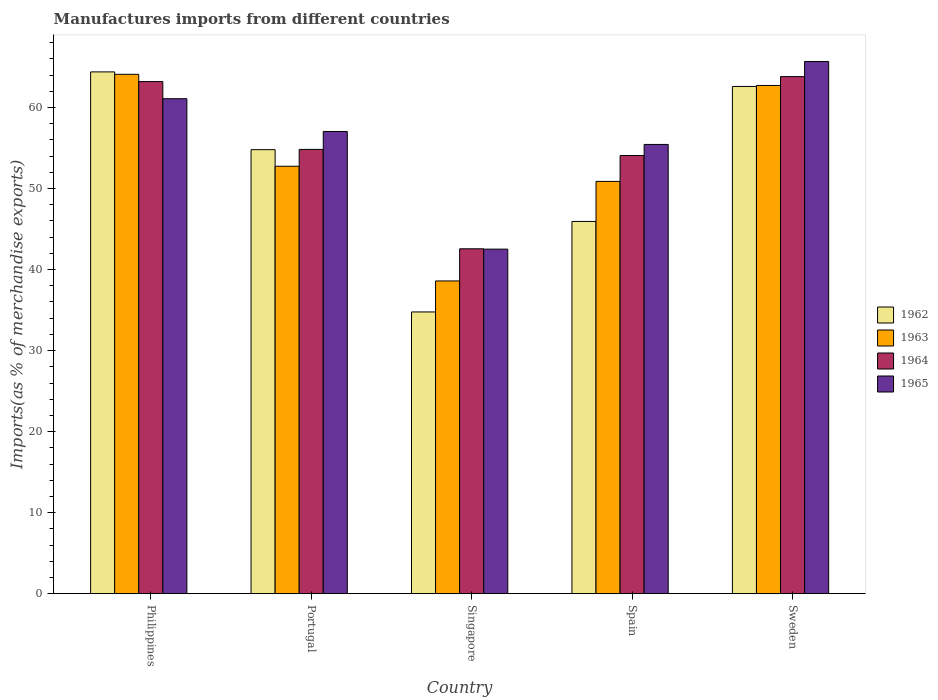Are the number of bars per tick equal to the number of legend labels?
Offer a very short reply. Yes. Are the number of bars on each tick of the X-axis equal?
Your response must be concise. Yes. How many bars are there on the 3rd tick from the left?
Ensure brevity in your answer.  4. How many bars are there on the 5th tick from the right?
Your response must be concise. 4. What is the label of the 3rd group of bars from the left?
Your answer should be compact. Singapore. In how many cases, is the number of bars for a given country not equal to the number of legend labels?
Make the answer very short. 0. What is the percentage of imports to different countries in 1964 in Singapore?
Your response must be concise. 42.56. Across all countries, what is the maximum percentage of imports to different countries in 1963?
Your answer should be very brief. 64.1. Across all countries, what is the minimum percentage of imports to different countries in 1964?
Make the answer very short. 42.56. In which country was the percentage of imports to different countries in 1965 maximum?
Ensure brevity in your answer.  Sweden. In which country was the percentage of imports to different countries in 1964 minimum?
Your answer should be compact. Singapore. What is the total percentage of imports to different countries in 1962 in the graph?
Provide a short and direct response. 262.5. What is the difference between the percentage of imports to different countries in 1962 in Portugal and that in Sweden?
Your answer should be very brief. -7.8. What is the difference between the percentage of imports to different countries in 1965 in Philippines and the percentage of imports to different countries in 1963 in Sweden?
Make the answer very short. -1.64. What is the average percentage of imports to different countries in 1963 per country?
Make the answer very short. 53.81. What is the difference between the percentage of imports to different countries of/in 1964 and percentage of imports to different countries of/in 1963 in Singapore?
Your answer should be compact. 3.97. What is the ratio of the percentage of imports to different countries in 1963 in Portugal to that in Spain?
Ensure brevity in your answer.  1.04. Is the percentage of imports to different countries in 1962 in Philippines less than that in Sweden?
Your response must be concise. No. Is the difference between the percentage of imports to different countries in 1964 in Portugal and Spain greater than the difference between the percentage of imports to different countries in 1963 in Portugal and Spain?
Give a very brief answer. No. What is the difference between the highest and the second highest percentage of imports to different countries in 1963?
Provide a succinct answer. 11.35. What is the difference between the highest and the lowest percentage of imports to different countries in 1964?
Offer a very short reply. 21.25. In how many countries, is the percentage of imports to different countries in 1962 greater than the average percentage of imports to different countries in 1962 taken over all countries?
Ensure brevity in your answer.  3. What does the 1st bar from the right in Philippines represents?
Your answer should be compact. 1965. Is it the case that in every country, the sum of the percentage of imports to different countries in 1964 and percentage of imports to different countries in 1962 is greater than the percentage of imports to different countries in 1965?
Ensure brevity in your answer.  Yes. How many countries are there in the graph?
Your answer should be compact. 5. What is the difference between two consecutive major ticks on the Y-axis?
Ensure brevity in your answer.  10. Are the values on the major ticks of Y-axis written in scientific E-notation?
Give a very brief answer. No. Where does the legend appear in the graph?
Your answer should be very brief. Center right. How many legend labels are there?
Offer a very short reply. 4. How are the legend labels stacked?
Your response must be concise. Vertical. What is the title of the graph?
Offer a terse response. Manufactures imports from different countries. What is the label or title of the Y-axis?
Your answer should be very brief. Imports(as % of merchandise exports). What is the Imports(as % of merchandise exports) in 1962 in Philippines?
Make the answer very short. 64.4. What is the Imports(as % of merchandise exports) in 1963 in Philippines?
Keep it short and to the point. 64.1. What is the Imports(as % of merchandise exports) in 1964 in Philippines?
Offer a very short reply. 63.2. What is the Imports(as % of merchandise exports) of 1965 in Philippines?
Offer a terse response. 61.09. What is the Imports(as % of merchandise exports) in 1962 in Portugal?
Make the answer very short. 54.8. What is the Imports(as % of merchandise exports) in 1963 in Portugal?
Keep it short and to the point. 52.75. What is the Imports(as % of merchandise exports) in 1964 in Portugal?
Ensure brevity in your answer.  54.83. What is the Imports(as % of merchandise exports) of 1965 in Portugal?
Offer a very short reply. 57.04. What is the Imports(as % of merchandise exports) in 1962 in Singapore?
Your answer should be compact. 34.77. What is the Imports(as % of merchandise exports) in 1963 in Singapore?
Your answer should be compact. 38.6. What is the Imports(as % of merchandise exports) in 1964 in Singapore?
Ensure brevity in your answer.  42.56. What is the Imports(as % of merchandise exports) of 1965 in Singapore?
Provide a short and direct response. 42.52. What is the Imports(as % of merchandise exports) of 1962 in Spain?
Give a very brief answer. 45.94. What is the Imports(as % of merchandise exports) in 1963 in Spain?
Your response must be concise. 50.88. What is the Imports(as % of merchandise exports) in 1964 in Spain?
Make the answer very short. 54.08. What is the Imports(as % of merchandise exports) in 1965 in Spain?
Ensure brevity in your answer.  55.44. What is the Imports(as % of merchandise exports) in 1962 in Sweden?
Your answer should be compact. 62.6. What is the Imports(as % of merchandise exports) of 1963 in Sweden?
Ensure brevity in your answer.  62.72. What is the Imports(as % of merchandise exports) of 1964 in Sweden?
Provide a short and direct response. 63.82. What is the Imports(as % of merchandise exports) in 1965 in Sweden?
Make the answer very short. 65.68. Across all countries, what is the maximum Imports(as % of merchandise exports) in 1962?
Provide a succinct answer. 64.4. Across all countries, what is the maximum Imports(as % of merchandise exports) of 1963?
Your response must be concise. 64.1. Across all countries, what is the maximum Imports(as % of merchandise exports) in 1964?
Provide a succinct answer. 63.82. Across all countries, what is the maximum Imports(as % of merchandise exports) of 1965?
Your answer should be very brief. 65.68. Across all countries, what is the minimum Imports(as % of merchandise exports) in 1962?
Ensure brevity in your answer.  34.77. Across all countries, what is the minimum Imports(as % of merchandise exports) of 1963?
Offer a very short reply. 38.6. Across all countries, what is the minimum Imports(as % of merchandise exports) of 1964?
Make the answer very short. 42.56. Across all countries, what is the minimum Imports(as % of merchandise exports) of 1965?
Your answer should be compact. 42.52. What is the total Imports(as % of merchandise exports) of 1962 in the graph?
Your answer should be compact. 262.5. What is the total Imports(as % of merchandise exports) of 1963 in the graph?
Provide a succinct answer. 269.05. What is the total Imports(as % of merchandise exports) in 1964 in the graph?
Keep it short and to the point. 278.49. What is the total Imports(as % of merchandise exports) of 1965 in the graph?
Provide a short and direct response. 281.78. What is the difference between the Imports(as % of merchandise exports) in 1962 in Philippines and that in Portugal?
Keep it short and to the point. 9.6. What is the difference between the Imports(as % of merchandise exports) in 1963 in Philippines and that in Portugal?
Provide a succinct answer. 11.35. What is the difference between the Imports(as % of merchandise exports) of 1964 in Philippines and that in Portugal?
Your answer should be very brief. 8.37. What is the difference between the Imports(as % of merchandise exports) in 1965 in Philippines and that in Portugal?
Provide a succinct answer. 4.04. What is the difference between the Imports(as % of merchandise exports) of 1962 in Philippines and that in Singapore?
Make the answer very short. 29.63. What is the difference between the Imports(as % of merchandise exports) of 1963 in Philippines and that in Singapore?
Provide a short and direct response. 25.5. What is the difference between the Imports(as % of merchandise exports) of 1964 in Philippines and that in Singapore?
Offer a very short reply. 20.64. What is the difference between the Imports(as % of merchandise exports) of 1965 in Philippines and that in Singapore?
Offer a terse response. 18.57. What is the difference between the Imports(as % of merchandise exports) of 1962 in Philippines and that in Spain?
Your answer should be very brief. 18.46. What is the difference between the Imports(as % of merchandise exports) of 1963 in Philippines and that in Spain?
Your answer should be very brief. 13.22. What is the difference between the Imports(as % of merchandise exports) in 1964 in Philippines and that in Spain?
Give a very brief answer. 9.12. What is the difference between the Imports(as % of merchandise exports) in 1965 in Philippines and that in Spain?
Offer a terse response. 5.64. What is the difference between the Imports(as % of merchandise exports) of 1962 in Philippines and that in Sweden?
Your answer should be compact. 1.8. What is the difference between the Imports(as % of merchandise exports) in 1963 in Philippines and that in Sweden?
Provide a short and direct response. 1.37. What is the difference between the Imports(as % of merchandise exports) of 1964 in Philippines and that in Sweden?
Ensure brevity in your answer.  -0.61. What is the difference between the Imports(as % of merchandise exports) in 1965 in Philippines and that in Sweden?
Offer a terse response. -4.6. What is the difference between the Imports(as % of merchandise exports) of 1962 in Portugal and that in Singapore?
Your response must be concise. 20.03. What is the difference between the Imports(as % of merchandise exports) of 1963 in Portugal and that in Singapore?
Keep it short and to the point. 14.16. What is the difference between the Imports(as % of merchandise exports) of 1964 in Portugal and that in Singapore?
Provide a short and direct response. 12.27. What is the difference between the Imports(as % of merchandise exports) of 1965 in Portugal and that in Singapore?
Offer a very short reply. 14.52. What is the difference between the Imports(as % of merchandise exports) of 1962 in Portugal and that in Spain?
Your response must be concise. 8.86. What is the difference between the Imports(as % of merchandise exports) in 1963 in Portugal and that in Spain?
Make the answer very short. 1.87. What is the difference between the Imports(as % of merchandise exports) in 1964 in Portugal and that in Spain?
Give a very brief answer. 0.75. What is the difference between the Imports(as % of merchandise exports) of 1965 in Portugal and that in Spain?
Give a very brief answer. 1.6. What is the difference between the Imports(as % of merchandise exports) of 1962 in Portugal and that in Sweden?
Provide a short and direct response. -7.8. What is the difference between the Imports(as % of merchandise exports) in 1963 in Portugal and that in Sweden?
Your answer should be compact. -9.97. What is the difference between the Imports(as % of merchandise exports) in 1964 in Portugal and that in Sweden?
Your answer should be compact. -8.99. What is the difference between the Imports(as % of merchandise exports) in 1965 in Portugal and that in Sweden?
Your response must be concise. -8.64. What is the difference between the Imports(as % of merchandise exports) of 1962 in Singapore and that in Spain?
Provide a succinct answer. -11.17. What is the difference between the Imports(as % of merchandise exports) in 1963 in Singapore and that in Spain?
Your response must be concise. -12.29. What is the difference between the Imports(as % of merchandise exports) of 1964 in Singapore and that in Spain?
Your answer should be very brief. -11.51. What is the difference between the Imports(as % of merchandise exports) of 1965 in Singapore and that in Spain?
Your answer should be very brief. -12.92. What is the difference between the Imports(as % of merchandise exports) of 1962 in Singapore and that in Sweden?
Provide a succinct answer. -27.83. What is the difference between the Imports(as % of merchandise exports) of 1963 in Singapore and that in Sweden?
Provide a short and direct response. -24.13. What is the difference between the Imports(as % of merchandise exports) in 1964 in Singapore and that in Sweden?
Make the answer very short. -21.25. What is the difference between the Imports(as % of merchandise exports) of 1965 in Singapore and that in Sweden?
Make the answer very short. -23.16. What is the difference between the Imports(as % of merchandise exports) of 1962 in Spain and that in Sweden?
Offer a terse response. -16.66. What is the difference between the Imports(as % of merchandise exports) in 1963 in Spain and that in Sweden?
Provide a short and direct response. -11.84. What is the difference between the Imports(as % of merchandise exports) in 1964 in Spain and that in Sweden?
Offer a very short reply. -9.74. What is the difference between the Imports(as % of merchandise exports) of 1965 in Spain and that in Sweden?
Your answer should be compact. -10.24. What is the difference between the Imports(as % of merchandise exports) in 1962 in Philippines and the Imports(as % of merchandise exports) in 1963 in Portugal?
Offer a terse response. 11.65. What is the difference between the Imports(as % of merchandise exports) in 1962 in Philippines and the Imports(as % of merchandise exports) in 1964 in Portugal?
Provide a short and direct response. 9.57. What is the difference between the Imports(as % of merchandise exports) of 1962 in Philippines and the Imports(as % of merchandise exports) of 1965 in Portugal?
Provide a short and direct response. 7.35. What is the difference between the Imports(as % of merchandise exports) in 1963 in Philippines and the Imports(as % of merchandise exports) in 1964 in Portugal?
Your answer should be compact. 9.27. What is the difference between the Imports(as % of merchandise exports) in 1963 in Philippines and the Imports(as % of merchandise exports) in 1965 in Portugal?
Ensure brevity in your answer.  7.05. What is the difference between the Imports(as % of merchandise exports) in 1964 in Philippines and the Imports(as % of merchandise exports) in 1965 in Portugal?
Ensure brevity in your answer.  6.16. What is the difference between the Imports(as % of merchandise exports) of 1962 in Philippines and the Imports(as % of merchandise exports) of 1963 in Singapore?
Your answer should be compact. 25.8. What is the difference between the Imports(as % of merchandise exports) of 1962 in Philippines and the Imports(as % of merchandise exports) of 1964 in Singapore?
Your answer should be compact. 21.83. What is the difference between the Imports(as % of merchandise exports) in 1962 in Philippines and the Imports(as % of merchandise exports) in 1965 in Singapore?
Your answer should be very brief. 21.87. What is the difference between the Imports(as % of merchandise exports) of 1963 in Philippines and the Imports(as % of merchandise exports) of 1964 in Singapore?
Make the answer very short. 21.53. What is the difference between the Imports(as % of merchandise exports) of 1963 in Philippines and the Imports(as % of merchandise exports) of 1965 in Singapore?
Your answer should be compact. 21.58. What is the difference between the Imports(as % of merchandise exports) of 1964 in Philippines and the Imports(as % of merchandise exports) of 1965 in Singapore?
Provide a short and direct response. 20.68. What is the difference between the Imports(as % of merchandise exports) in 1962 in Philippines and the Imports(as % of merchandise exports) in 1963 in Spain?
Your answer should be compact. 13.51. What is the difference between the Imports(as % of merchandise exports) of 1962 in Philippines and the Imports(as % of merchandise exports) of 1964 in Spain?
Your answer should be compact. 10.32. What is the difference between the Imports(as % of merchandise exports) in 1962 in Philippines and the Imports(as % of merchandise exports) in 1965 in Spain?
Provide a succinct answer. 8.95. What is the difference between the Imports(as % of merchandise exports) of 1963 in Philippines and the Imports(as % of merchandise exports) of 1964 in Spain?
Your answer should be very brief. 10.02. What is the difference between the Imports(as % of merchandise exports) of 1963 in Philippines and the Imports(as % of merchandise exports) of 1965 in Spain?
Your answer should be compact. 8.65. What is the difference between the Imports(as % of merchandise exports) in 1964 in Philippines and the Imports(as % of merchandise exports) in 1965 in Spain?
Your response must be concise. 7.76. What is the difference between the Imports(as % of merchandise exports) of 1962 in Philippines and the Imports(as % of merchandise exports) of 1963 in Sweden?
Offer a terse response. 1.67. What is the difference between the Imports(as % of merchandise exports) in 1962 in Philippines and the Imports(as % of merchandise exports) in 1964 in Sweden?
Offer a terse response. 0.58. What is the difference between the Imports(as % of merchandise exports) in 1962 in Philippines and the Imports(as % of merchandise exports) in 1965 in Sweden?
Offer a very short reply. -1.29. What is the difference between the Imports(as % of merchandise exports) of 1963 in Philippines and the Imports(as % of merchandise exports) of 1964 in Sweden?
Provide a short and direct response. 0.28. What is the difference between the Imports(as % of merchandise exports) of 1963 in Philippines and the Imports(as % of merchandise exports) of 1965 in Sweden?
Provide a succinct answer. -1.58. What is the difference between the Imports(as % of merchandise exports) in 1964 in Philippines and the Imports(as % of merchandise exports) in 1965 in Sweden?
Provide a short and direct response. -2.48. What is the difference between the Imports(as % of merchandise exports) of 1962 in Portugal and the Imports(as % of merchandise exports) of 1963 in Singapore?
Your answer should be compact. 16.2. What is the difference between the Imports(as % of merchandise exports) in 1962 in Portugal and the Imports(as % of merchandise exports) in 1964 in Singapore?
Make the answer very short. 12.23. What is the difference between the Imports(as % of merchandise exports) in 1962 in Portugal and the Imports(as % of merchandise exports) in 1965 in Singapore?
Ensure brevity in your answer.  12.28. What is the difference between the Imports(as % of merchandise exports) of 1963 in Portugal and the Imports(as % of merchandise exports) of 1964 in Singapore?
Keep it short and to the point. 10.19. What is the difference between the Imports(as % of merchandise exports) of 1963 in Portugal and the Imports(as % of merchandise exports) of 1965 in Singapore?
Offer a very short reply. 10.23. What is the difference between the Imports(as % of merchandise exports) in 1964 in Portugal and the Imports(as % of merchandise exports) in 1965 in Singapore?
Keep it short and to the point. 12.31. What is the difference between the Imports(as % of merchandise exports) in 1962 in Portugal and the Imports(as % of merchandise exports) in 1963 in Spain?
Your answer should be compact. 3.92. What is the difference between the Imports(as % of merchandise exports) of 1962 in Portugal and the Imports(as % of merchandise exports) of 1964 in Spain?
Keep it short and to the point. 0.72. What is the difference between the Imports(as % of merchandise exports) in 1962 in Portugal and the Imports(as % of merchandise exports) in 1965 in Spain?
Offer a very short reply. -0.65. What is the difference between the Imports(as % of merchandise exports) of 1963 in Portugal and the Imports(as % of merchandise exports) of 1964 in Spain?
Make the answer very short. -1.33. What is the difference between the Imports(as % of merchandise exports) in 1963 in Portugal and the Imports(as % of merchandise exports) in 1965 in Spain?
Provide a succinct answer. -2.69. What is the difference between the Imports(as % of merchandise exports) in 1964 in Portugal and the Imports(as % of merchandise exports) in 1965 in Spain?
Keep it short and to the point. -0.61. What is the difference between the Imports(as % of merchandise exports) in 1962 in Portugal and the Imports(as % of merchandise exports) in 1963 in Sweden?
Make the answer very short. -7.92. What is the difference between the Imports(as % of merchandise exports) in 1962 in Portugal and the Imports(as % of merchandise exports) in 1964 in Sweden?
Your response must be concise. -9.02. What is the difference between the Imports(as % of merchandise exports) in 1962 in Portugal and the Imports(as % of merchandise exports) in 1965 in Sweden?
Make the answer very short. -10.88. What is the difference between the Imports(as % of merchandise exports) of 1963 in Portugal and the Imports(as % of merchandise exports) of 1964 in Sweden?
Give a very brief answer. -11.07. What is the difference between the Imports(as % of merchandise exports) of 1963 in Portugal and the Imports(as % of merchandise exports) of 1965 in Sweden?
Keep it short and to the point. -12.93. What is the difference between the Imports(as % of merchandise exports) in 1964 in Portugal and the Imports(as % of merchandise exports) in 1965 in Sweden?
Your answer should be very brief. -10.85. What is the difference between the Imports(as % of merchandise exports) in 1962 in Singapore and the Imports(as % of merchandise exports) in 1963 in Spain?
Give a very brief answer. -16.11. What is the difference between the Imports(as % of merchandise exports) in 1962 in Singapore and the Imports(as % of merchandise exports) in 1964 in Spain?
Make the answer very short. -19.31. What is the difference between the Imports(as % of merchandise exports) in 1962 in Singapore and the Imports(as % of merchandise exports) in 1965 in Spain?
Provide a succinct answer. -20.68. What is the difference between the Imports(as % of merchandise exports) of 1963 in Singapore and the Imports(as % of merchandise exports) of 1964 in Spain?
Offer a very short reply. -15.48. What is the difference between the Imports(as % of merchandise exports) of 1963 in Singapore and the Imports(as % of merchandise exports) of 1965 in Spain?
Provide a succinct answer. -16.85. What is the difference between the Imports(as % of merchandise exports) in 1964 in Singapore and the Imports(as % of merchandise exports) in 1965 in Spain?
Your answer should be very brief. -12.88. What is the difference between the Imports(as % of merchandise exports) in 1962 in Singapore and the Imports(as % of merchandise exports) in 1963 in Sweden?
Offer a very short reply. -27.95. What is the difference between the Imports(as % of merchandise exports) in 1962 in Singapore and the Imports(as % of merchandise exports) in 1964 in Sweden?
Ensure brevity in your answer.  -29.05. What is the difference between the Imports(as % of merchandise exports) in 1962 in Singapore and the Imports(as % of merchandise exports) in 1965 in Sweden?
Provide a short and direct response. -30.91. What is the difference between the Imports(as % of merchandise exports) in 1963 in Singapore and the Imports(as % of merchandise exports) in 1964 in Sweden?
Keep it short and to the point. -25.22. What is the difference between the Imports(as % of merchandise exports) in 1963 in Singapore and the Imports(as % of merchandise exports) in 1965 in Sweden?
Keep it short and to the point. -27.09. What is the difference between the Imports(as % of merchandise exports) of 1964 in Singapore and the Imports(as % of merchandise exports) of 1965 in Sweden?
Offer a terse response. -23.12. What is the difference between the Imports(as % of merchandise exports) in 1962 in Spain and the Imports(as % of merchandise exports) in 1963 in Sweden?
Offer a terse response. -16.78. What is the difference between the Imports(as % of merchandise exports) of 1962 in Spain and the Imports(as % of merchandise exports) of 1964 in Sweden?
Provide a short and direct response. -17.88. What is the difference between the Imports(as % of merchandise exports) of 1962 in Spain and the Imports(as % of merchandise exports) of 1965 in Sweden?
Your answer should be very brief. -19.74. What is the difference between the Imports(as % of merchandise exports) in 1963 in Spain and the Imports(as % of merchandise exports) in 1964 in Sweden?
Your answer should be very brief. -12.94. What is the difference between the Imports(as % of merchandise exports) in 1963 in Spain and the Imports(as % of merchandise exports) in 1965 in Sweden?
Make the answer very short. -14.8. What is the difference between the Imports(as % of merchandise exports) in 1964 in Spain and the Imports(as % of merchandise exports) in 1965 in Sweden?
Your response must be concise. -11.6. What is the average Imports(as % of merchandise exports) in 1962 per country?
Your answer should be compact. 52.5. What is the average Imports(as % of merchandise exports) of 1963 per country?
Make the answer very short. 53.81. What is the average Imports(as % of merchandise exports) in 1964 per country?
Offer a terse response. 55.7. What is the average Imports(as % of merchandise exports) of 1965 per country?
Offer a very short reply. 56.36. What is the difference between the Imports(as % of merchandise exports) of 1962 and Imports(as % of merchandise exports) of 1963 in Philippines?
Your answer should be very brief. 0.3. What is the difference between the Imports(as % of merchandise exports) of 1962 and Imports(as % of merchandise exports) of 1964 in Philippines?
Offer a terse response. 1.19. What is the difference between the Imports(as % of merchandise exports) of 1962 and Imports(as % of merchandise exports) of 1965 in Philippines?
Offer a terse response. 3.31. What is the difference between the Imports(as % of merchandise exports) of 1963 and Imports(as % of merchandise exports) of 1964 in Philippines?
Provide a short and direct response. 0.89. What is the difference between the Imports(as % of merchandise exports) of 1963 and Imports(as % of merchandise exports) of 1965 in Philippines?
Give a very brief answer. 3.01. What is the difference between the Imports(as % of merchandise exports) in 1964 and Imports(as % of merchandise exports) in 1965 in Philippines?
Your answer should be compact. 2.12. What is the difference between the Imports(as % of merchandise exports) in 1962 and Imports(as % of merchandise exports) in 1963 in Portugal?
Keep it short and to the point. 2.05. What is the difference between the Imports(as % of merchandise exports) of 1962 and Imports(as % of merchandise exports) of 1964 in Portugal?
Your answer should be compact. -0.03. What is the difference between the Imports(as % of merchandise exports) in 1962 and Imports(as % of merchandise exports) in 1965 in Portugal?
Offer a very short reply. -2.24. What is the difference between the Imports(as % of merchandise exports) of 1963 and Imports(as % of merchandise exports) of 1964 in Portugal?
Offer a terse response. -2.08. What is the difference between the Imports(as % of merchandise exports) in 1963 and Imports(as % of merchandise exports) in 1965 in Portugal?
Your answer should be compact. -4.29. What is the difference between the Imports(as % of merchandise exports) in 1964 and Imports(as % of merchandise exports) in 1965 in Portugal?
Give a very brief answer. -2.21. What is the difference between the Imports(as % of merchandise exports) in 1962 and Imports(as % of merchandise exports) in 1963 in Singapore?
Give a very brief answer. -3.83. What is the difference between the Imports(as % of merchandise exports) in 1962 and Imports(as % of merchandise exports) in 1964 in Singapore?
Offer a very short reply. -7.8. What is the difference between the Imports(as % of merchandise exports) in 1962 and Imports(as % of merchandise exports) in 1965 in Singapore?
Ensure brevity in your answer.  -7.75. What is the difference between the Imports(as % of merchandise exports) in 1963 and Imports(as % of merchandise exports) in 1964 in Singapore?
Provide a short and direct response. -3.97. What is the difference between the Imports(as % of merchandise exports) in 1963 and Imports(as % of merchandise exports) in 1965 in Singapore?
Your answer should be compact. -3.93. What is the difference between the Imports(as % of merchandise exports) in 1964 and Imports(as % of merchandise exports) in 1965 in Singapore?
Ensure brevity in your answer.  0.04. What is the difference between the Imports(as % of merchandise exports) of 1962 and Imports(as % of merchandise exports) of 1963 in Spain?
Offer a very short reply. -4.94. What is the difference between the Imports(as % of merchandise exports) in 1962 and Imports(as % of merchandise exports) in 1964 in Spain?
Give a very brief answer. -8.14. What is the difference between the Imports(as % of merchandise exports) of 1962 and Imports(as % of merchandise exports) of 1965 in Spain?
Your answer should be compact. -9.51. What is the difference between the Imports(as % of merchandise exports) in 1963 and Imports(as % of merchandise exports) in 1964 in Spain?
Keep it short and to the point. -3.2. What is the difference between the Imports(as % of merchandise exports) in 1963 and Imports(as % of merchandise exports) in 1965 in Spain?
Your answer should be very brief. -4.56. What is the difference between the Imports(as % of merchandise exports) of 1964 and Imports(as % of merchandise exports) of 1965 in Spain?
Your answer should be very brief. -1.37. What is the difference between the Imports(as % of merchandise exports) of 1962 and Imports(as % of merchandise exports) of 1963 in Sweden?
Offer a very short reply. -0.12. What is the difference between the Imports(as % of merchandise exports) of 1962 and Imports(as % of merchandise exports) of 1964 in Sweden?
Offer a terse response. -1.22. What is the difference between the Imports(as % of merchandise exports) in 1962 and Imports(as % of merchandise exports) in 1965 in Sweden?
Offer a terse response. -3.08. What is the difference between the Imports(as % of merchandise exports) in 1963 and Imports(as % of merchandise exports) in 1964 in Sweden?
Make the answer very short. -1.09. What is the difference between the Imports(as % of merchandise exports) in 1963 and Imports(as % of merchandise exports) in 1965 in Sweden?
Offer a terse response. -2.96. What is the difference between the Imports(as % of merchandise exports) in 1964 and Imports(as % of merchandise exports) in 1965 in Sweden?
Your answer should be compact. -1.87. What is the ratio of the Imports(as % of merchandise exports) in 1962 in Philippines to that in Portugal?
Provide a succinct answer. 1.18. What is the ratio of the Imports(as % of merchandise exports) of 1963 in Philippines to that in Portugal?
Provide a succinct answer. 1.22. What is the ratio of the Imports(as % of merchandise exports) of 1964 in Philippines to that in Portugal?
Make the answer very short. 1.15. What is the ratio of the Imports(as % of merchandise exports) in 1965 in Philippines to that in Portugal?
Your answer should be very brief. 1.07. What is the ratio of the Imports(as % of merchandise exports) of 1962 in Philippines to that in Singapore?
Your response must be concise. 1.85. What is the ratio of the Imports(as % of merchandise exports) of 1963 in Philippines to that in Singapore?
Your answer should be very brief. 1.66. What is the ratio of the Imports(as % of merchandise exports) of 1964 in Philippines to that in Singapore?
Your answer should be compact. 1.48. What is the ratio of the Imports(as % of merchandise exports) in 1965 in Philippines to that in Singapore?
Offer a terse response. 1.44. What is the ratio of the Imports(as % of merchandise exports) in 1962 in Philippines to that in Spain?
Provide a short and direct response. 1.4. What is the ratio of the Imports(as % of merchandise exports) in 1963 in Philippines to that in Spain?
Make the answer very short. 1.26. What is the ratio of the Imports(as % of merchandise exports) of 1964 in Philippines to that in Spain?
Your answer should be compact. 1.17. What is the ratio of the Imports(as % of merchandise exports) of 1965 in Philippines to that in Spain?
Provide a succinct answer. 1.1. What is the ratio of the Imports(as % of merchandise exports) in 1962 in Philippines to that in Sweden?
Your response must be concise. 1.03. What is the ratio of the Imports(as % of merchandise exports) of 1963 in Philippines to that in Sweden?
Your answer should be compact. 1.02. What is the ratio of the Imports(as % of merchandise exports) in 1962 in Portugal to that in Singapore?
Make the answer very short. 1.58. What is the ratio of the Imports(as % of merchandise exports) in 1963 in Portugal to that in Singapore?
Your answer should be very brief. 1.37. What is the ratio of the Imports(as % of merchandise exports) of 1964 in Portugal to that in Singapore?
Ensure brevity in your answer.  1.29. What is the ratio of the Imports(as % of merchandise exports) in 1965 in Portugal to that in Singapore?
Make the answer very short. 1.34. What is the ratio of the Imports(as % of merchandise exports) of 1962 in Portugal to that in Spain?
Offer a terse response. 1.19. What is the ratio of the Imports(as % of merchandise exports) of 1963 in Portugal to that in Spain?
Provide a succinct answer. 1.04. What is the ratio of the Imports(as % of merchandise exports) in 1964 in Portugal to that in Spain?
Make the answer very short. 1.01. What is the ratio of the Imports(as % of merchandise exports) of 1965 in Portugal to that in Spain?
Keep it short and to the point. 1.03. What is the ratio of the Imports(as % of merchandise exports) in 1962 in Portugal to that in Sweden?
Provide a short and direct response. 0.88. What is the ratio of the Imports(as % of merchandise exports) of 1963 in Portugal to that in Sweden?
Make the answer very short. 0.84. What is the ratio of the Imports(as % of merchandise exports) of 1964 in Portugal to that in Sweden?
Your answer should be very brief. 0.86. What is the ratio of the Imports(as % of merchandise exports) in 1965 in Portugal to that in Sweden?
Make the answer very short. 0.87. What is the ratio of the Imports(as % of merchandise exports) of 1962 in Singapore to that in Spain?
Offer a terse response. 0.76. What is the ratio of the Imports(as % of merchandise exports) of 1963 in Singapore to that in Spain?
Your answer should be compact. 0.76. What is the ratio of the Imports(as % of merchandise exports) in 1964 in Singapore to that in Spain?
Keep it short and to the point. 0.79. What is the ratio of the Imports(as % of merchandise exports) of 1965 in Singapore to that in Spain?
Provide a succinct answer. 0.77. What is the ratio of the Imports(as % of merchandise exports) of 1962 in Singapore to that in Sweden?
Make the answer very short. 0.56. What is the ratio of the Imports(as % of merchandise exports) of 1963 in Singapore to that in Sweden?
Offer a terse response. 0.62. What is the ratio of the Imports(as % of merchandise exports) of 1964 in Singapore to that in Sweden?
Make the answer very short. 0.67. What is the ratio of the Imports(as % of merchandise exports) in 1965 in Singapore to that in Sweden?
Your answer should be very brief. 0.65. What is the ratio of the Imports(as % of merchandise exports) in 1962 in Spain to that in Sweden?
Keep it short and to the point. 0.73. What is the ratio of the Imports(as % of merchandise exports) in 1963 in Spain to that in Sweden?
Your answer should be compact. 0.81. What is the ratio of the Imports(as % of merchandise exports) of 1964 in Spain to that in Sweden?
Your answer should be very brief. 0.85. What is the ratio of the Imports(as % of merchandise exports) of 1965 in Spain to that in Sweden?
Ensure brevity in your answer.  0.84. What is the difference between the highest and the second highest Imports(as % of merchandise exports) of 1962?
Offer a terse response. 1.8. What is the difference between the highest and the second highest Imports(as % of merchandise exports) in 1963?
Your answer should be very brief. 1.37. What is the difference between the highest and the second highest Imports(as % of merchandise exports) of 1964?
Your answer should be compact. 0.61. What is the difference between the highest and the second highest Imports(as % of merchandise exports) in 1965?
Ensure brevity in your answer.  4.6. What is the difference between the highest and the lowest Imports(as % of merchandise exports) in 1962?
Provide a succinct answer. 29.63. What is the difference between the highest and the lowest Imports(as % of merchandise exports) in 1963?
Your answer should be very brief. 25.5. What is the difference between the highest and the lowest Imports(as % of merchandise exports) of 1964?
Your answer should be very brief. 21.25. What is the difference between the highest and the lowest Imports(as % of merchandise exports) of 1965?
Your response must be concise. 23.16. 